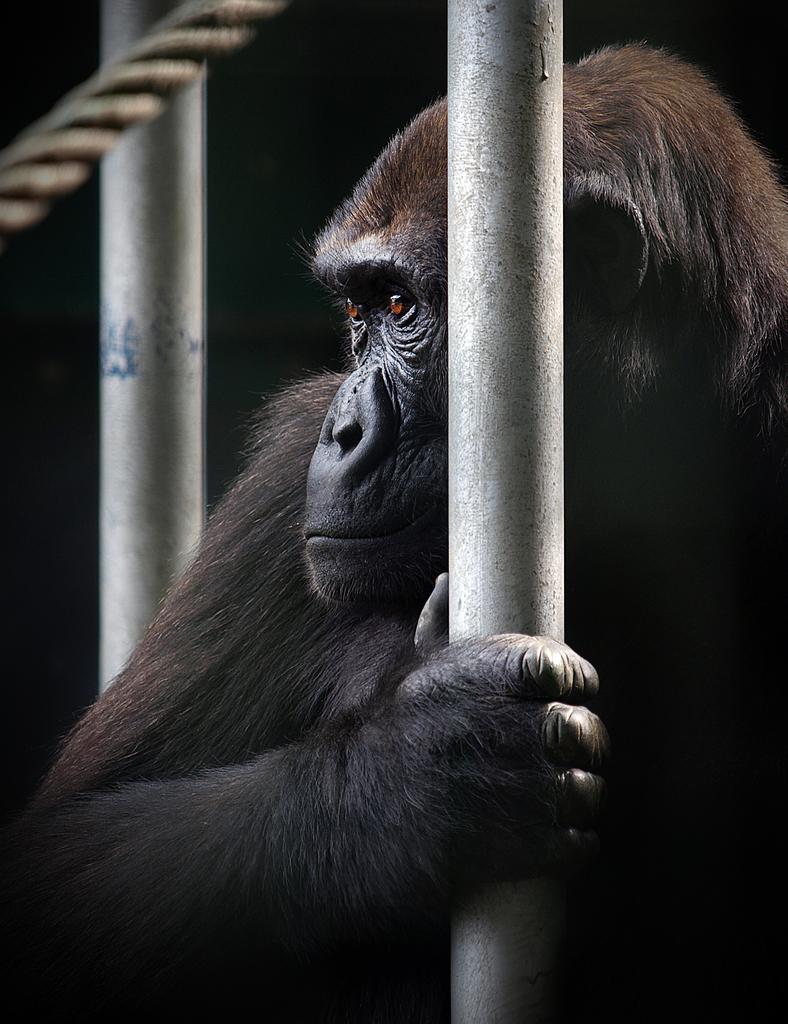Please provide a concise description of this image. In this image there is an animal holding the pole. Left side there is a pole. Left top there is a rope. 